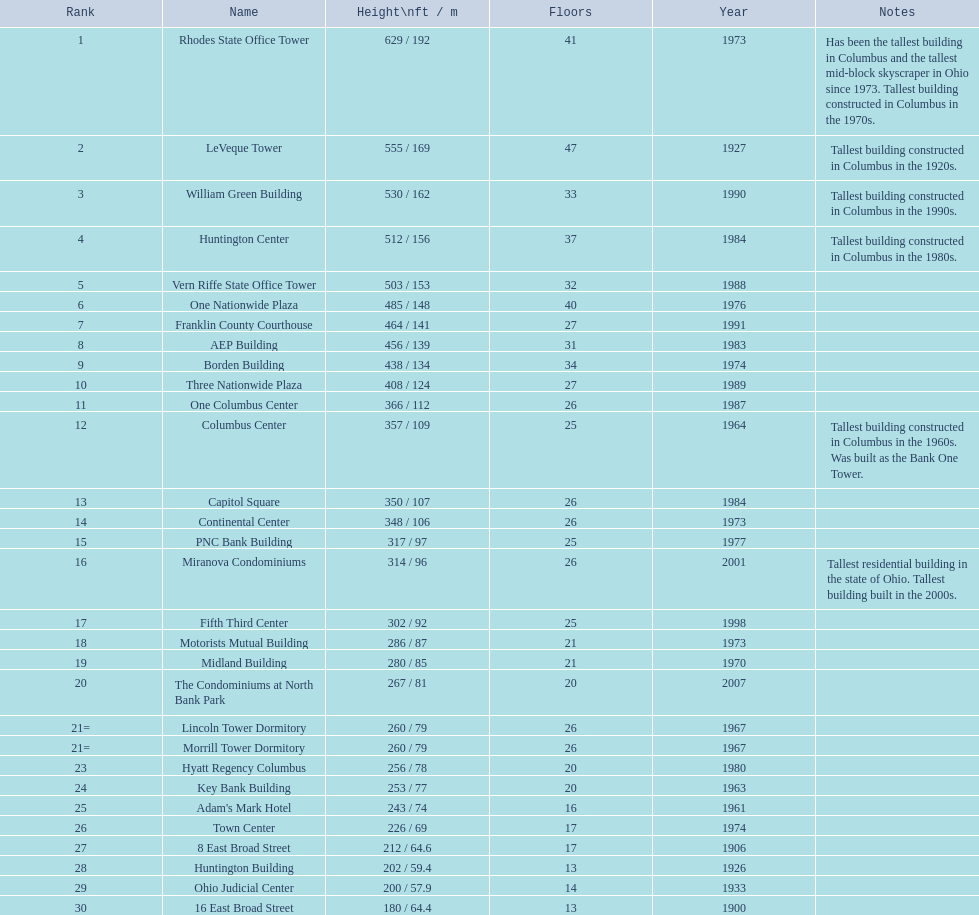What are the elevations of all the structures? 629 / 192, 555 / 169, 530 / 162, 512 / 156, 503 / 153, 485 / 148, 464 / 141, 456 / 139, 438 / 134, 408 / 124, 366 / 112, 357 / 109, 350 / 107, 348 / 106, 317 / 97, 314 / 96, 302 / 92, 286 / 87, 280 / 85, 267 / 81, 260 / 79, 260 / 79, 256 / 78, 253 / 77, 243 / 74, 226 / 69, 212 / 64.6, 202 / 59.4, 200 / 57.9, 180 / 64.4. What are the elevations of the aep and columbus center buildings? 456 / 139, 357 / 109. Which elevation is higher? 456 / 139. Which structure is this regarding? AEP Building. 